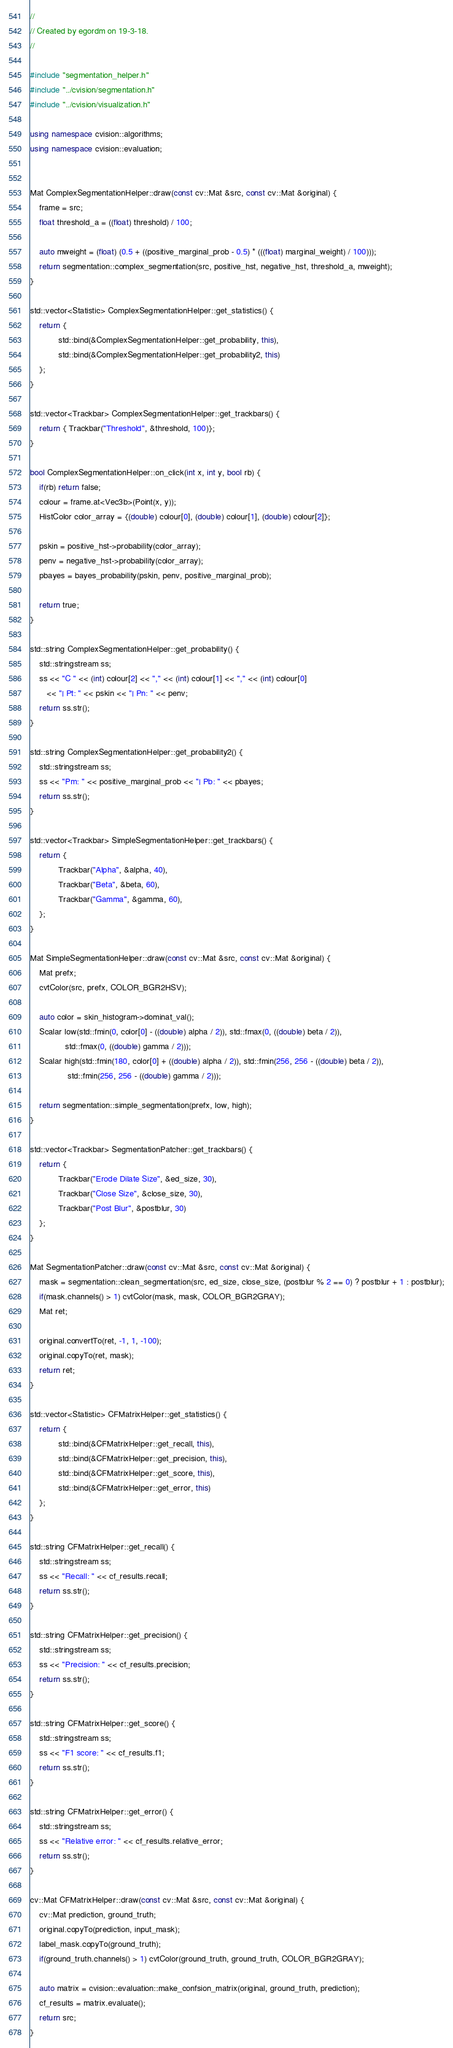<code> <loc_0><loc_0><loc_500><loc_500><_C++_>//
// Created by egordm on 19-3-18.
//

#include "segmentation_helper.h"
#include "../cvision/segmentation.h"
#include "../cvision/visualization.h"

using namespace cvision::algorithms;
using namespace cvision::evaluation;


Mat ComplexSegmentationHelper::draw(const cv::Mat &src, const cv::Mat &original) {
    frame = src;
    float threshold_a = ((float) threshold) / 100;

    auto mweight = (float) (0.5 + ((positive_marginal_prob - 0.5) * (((float) marginal_weight) / 100)));
    return segmentation::complex_segmentation(src, positive_hst, negative_hst, threshold_a, mweight);
}

std::vector<Statistic> ComplexSegmentationHelper::get_statistics() {
    return {
            std::bind(&ComplexSegmentationHelper::get_probability, this),
            std::bind(&ComplexSegmentationHelper::get_probability2, this)
    };
}

std::vector<Trackbar> ComplexSegmentationHelper::get_trackbars() {
    return { Trackbar("Threshold", &threshold, 100)};
}

bool ComplexSegmentationHelper::on_click(int x, int y, bool rb) {
    if(rb) return false;
    colour = frame.at<Vec3b>(Point(x, y));
    HistColor color_array = {(double) colour[0], (double) colour[1], (double) colour[2]};

    pskin = positive_hst->probability(color_array);
    penv = negative_hst->probability(color_array);
    pbayes = bayes_probability(pskin, penv, positive_marginal_prob);

    return true;
}

std::string ComplexSegmentationHelper::get_probability() {
    std::stringstream ss;
    ss << "C " << (int) colour[2] << "," << (int) colour[1] << "," << (int) colour[0]
       << "| Pt: " << pskin << "| Pn: " << penv;
    return ss.str();
}

std::string ComplexSegmentationHelper::get_probability2() {
    std::stringstream ss;
    ss << "Pm: " << positive_marginal_prob << "| Pb: " << pbayes;
    return ss.str();
}

std::vector<Trackbar> SimpleSegmentationHelper::get_trackbars() {
    return {
            Trackbar("Alpha", &alpha, 40),
            Trackbar("Beta", &beta, 60),
            Trackbar("Gamma", &gamma, 60),
    };
}

Mat SimpleSegmentationHelper::draw(const cv::Mat &src, const cv::Mat &original) {
    Mat prefx;
    cvtColor(src, prefx, COLOR_BGR2HSV);

    auto color = skin_histogram->dominat_val();
    Scalar low(std::fmin(0, color[0] - ((double) alpha / 2)), std::fmax(0, ((double) beta / 2)),
               std::fmax(0, ((double) gamma / 2)));
    Scalar high(std::fmin(180, color[0] + ((double) alpha / 2)), std::fmin(256, 256 - ((double) beta / 2)),
                std::fmin(256, 256 - ((double) gamma / 2)));

    return segmentation::simple_segmentation(prefx, low, high);
}

std::vector<Trackbar> SegmentationPatcher::get_trackbars() {
    return {
            Trackbar("Erode Dilate Size", &ed_size, 30),
            Trackbar("Close Size", &close_size, 30),
            Trackbar("Post Blur", &postblur, 30)
    };
}

Mat SegmentationPatcher::draw(const cv::Mat &src, const cv::Mat &original) {
    mask = segmentation::clean_segmentation(src, ed_size, close_size, (postblur % 2 == 0) ? postblur + 1 : postblur);
    if(mask.channels() > 1) cvtColor(mask, mask, COLOR_BGR2GRAY);
    Mat ret;

    original.convertTo(ret, -1, 1, -100);
    original.copyTo(ret, mask);
    return ret;
}

std::vector<Statistic> CFMatrixHelper::get_statistics() {
    return {
            std::bind(&CFMatrixHelper::get_recall, this),
            std::bind(&CFMatrixHelper::get_precision, this),
            std::bind(&CFMatrixHelper::get_score, this),
            std::bind(&CFMatrixHelper::get_error, this)
    };
}

std::string CFMatrixHelper::get_recall() {
    std::stringstream ss;
    ss << "Recall: " << cf_results.recall;
    return ss.str();
}

std::string CFMatrixHelper::get_precision() {
    std::stringstream ss;
    ss << "Precision: " << cf_results.precision;
    return ss.str();
}

std::string CFMatrixHelper::get_score() {
    std::stringstream ss;
    ss << "F1 score: " << cf_results.f1;
    return ss.str();
}

std::string CFMatrixHelper::get_error() {
    std::stringstream ss;
    ss << "Relative error: " << cf_results.relative_error;
    return ss.str();
}

cv::Mat CFMatrixHelper::draw(const cv::Mat &src, const cv::Mat &original) {
    cv::Mat prediction, ground_truth;
    original.copyTo(prediction, input_mask);
    label_mask.copyTo(ground_truth);
    if(ground_truth.channels() > 1) cvtColor(ground_truth, ground_truth, COLOR_BGR2GRAY);

    auto matrix = cvision::evaluation::make_confsion_matrix(original, ground_truth, prediction);
    cf_results = matrix.evaluate();
    return src;
}</code> 